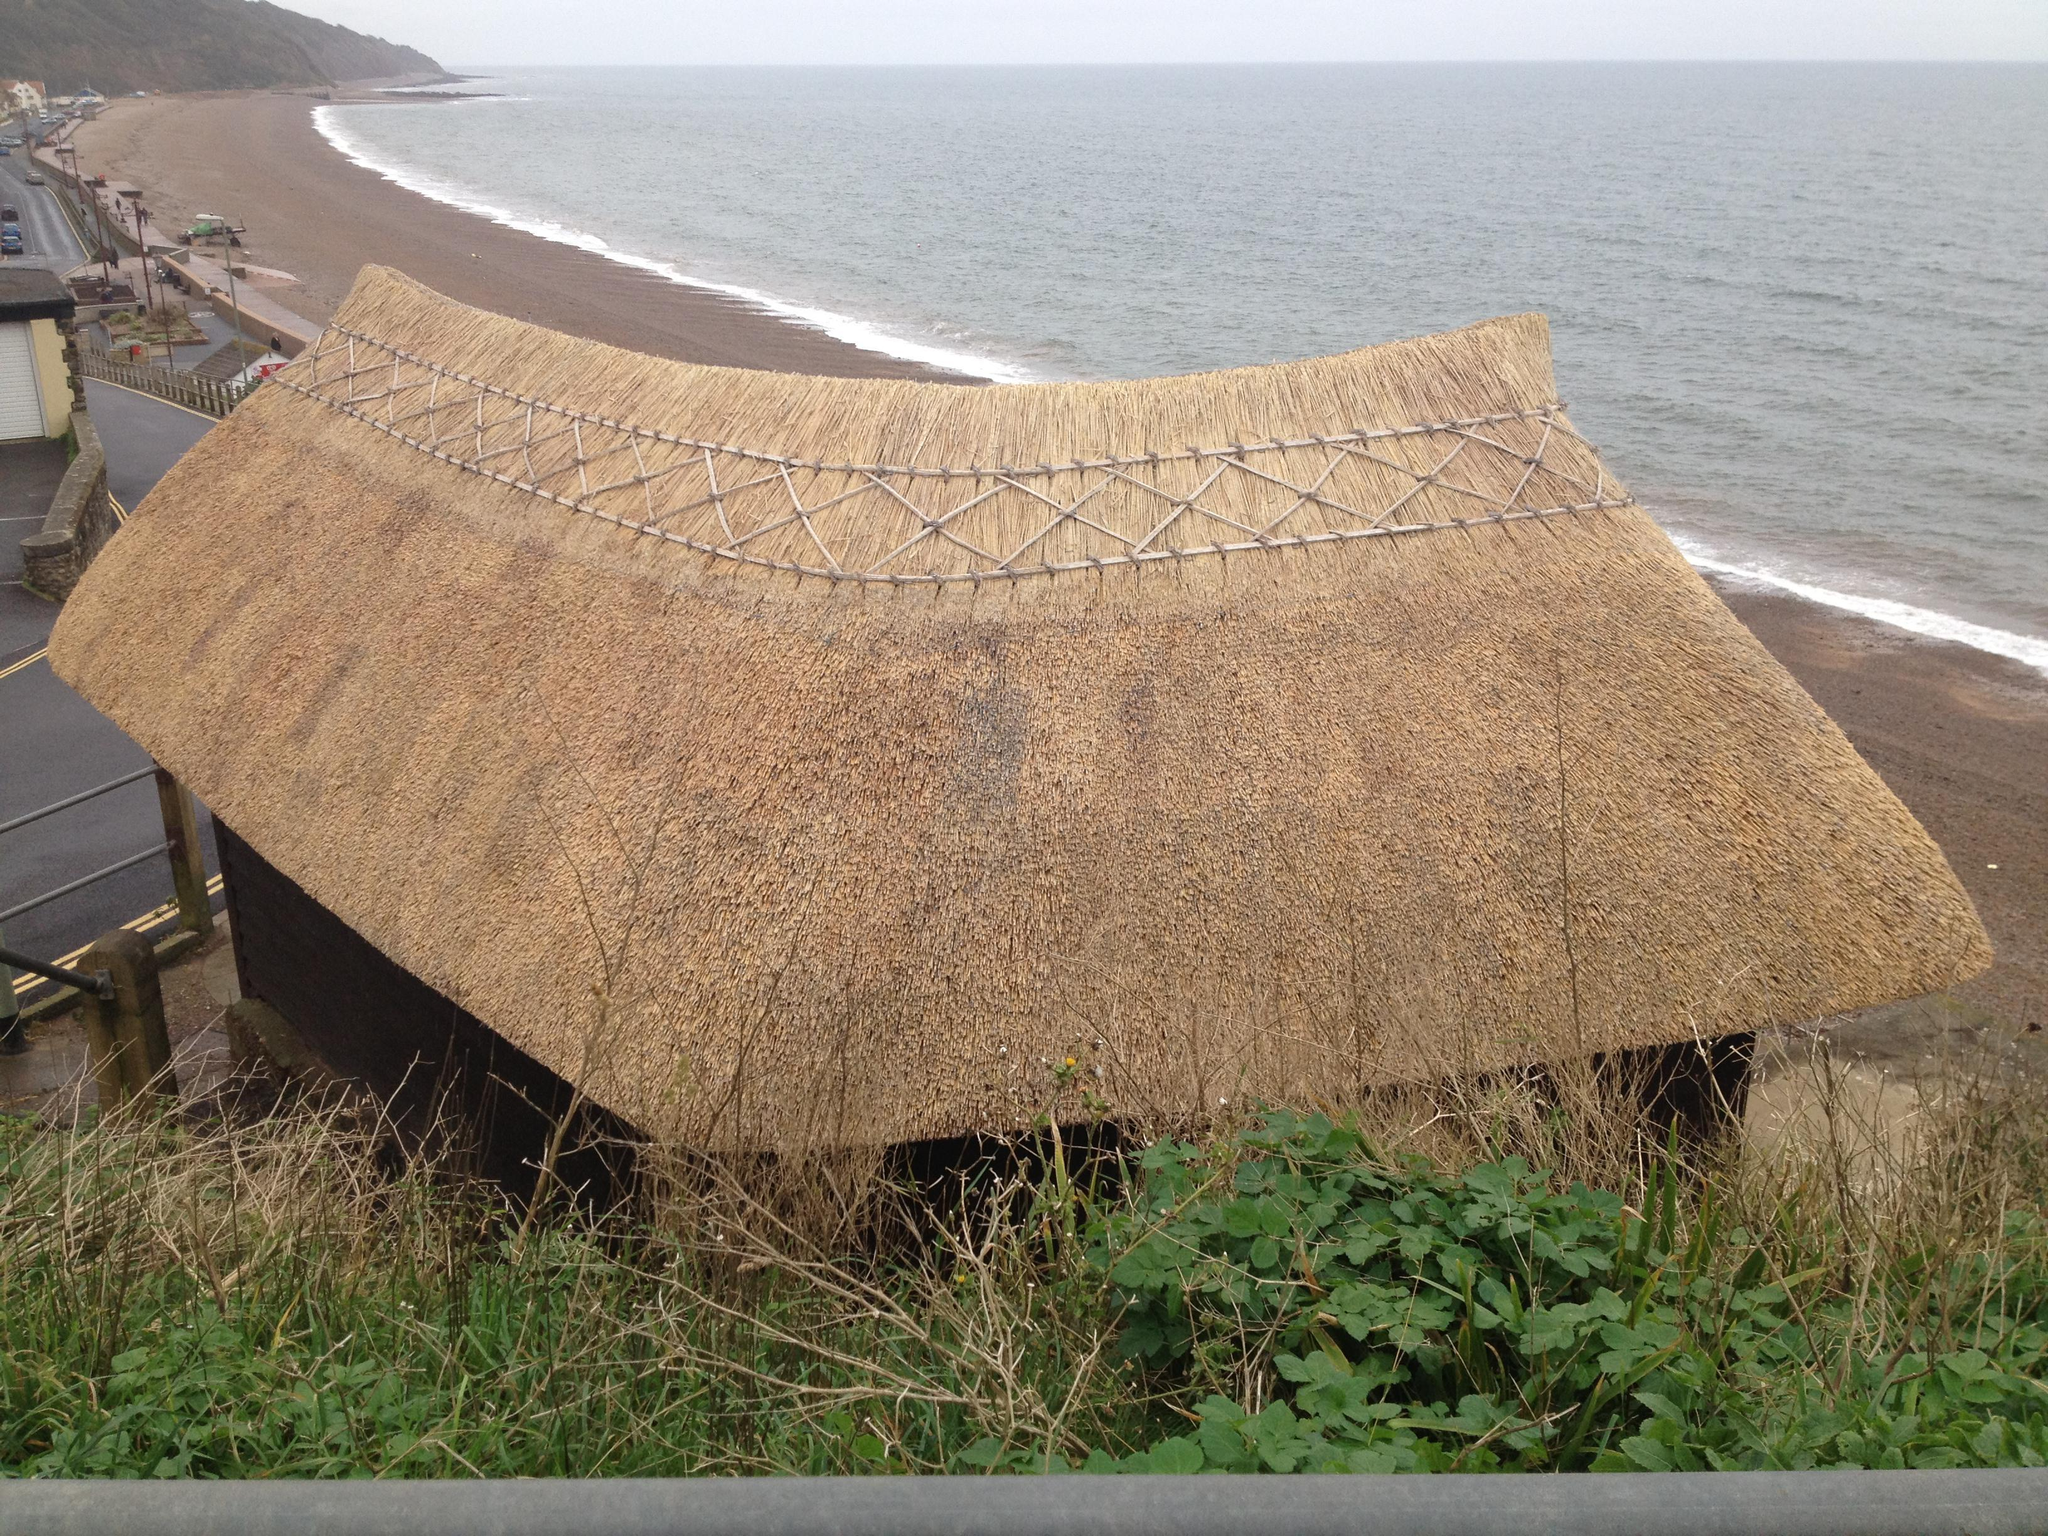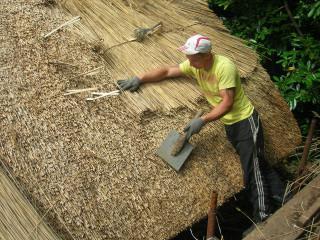The first image is the image on the left, the second image is the image on the right. Considering the images on both sides, is "There is at least one aluminum ladder leaning against a thatched roof." valid? Answer yes or no. No. The first image is the image on the left, the second image is the image on the right. For the images displayed, is the sentence "A man is standing on the roof in one of the images." factually correct? Answer yes or no. Yes. 